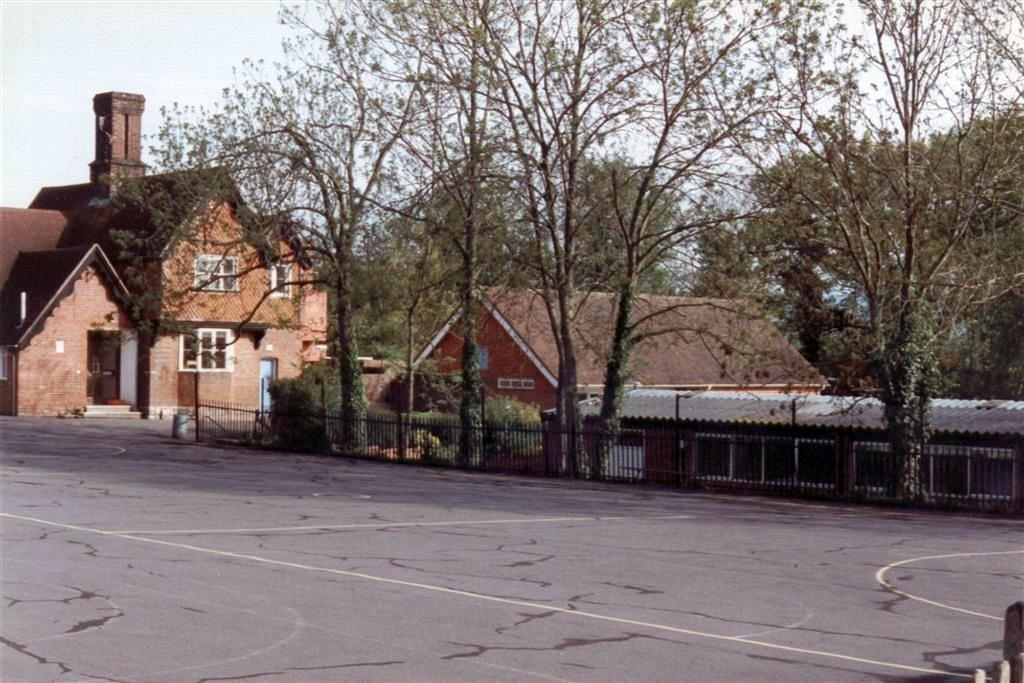Can you describe this image briefly? In this image there are road, metal rod fence, bushes, trees and houses. 